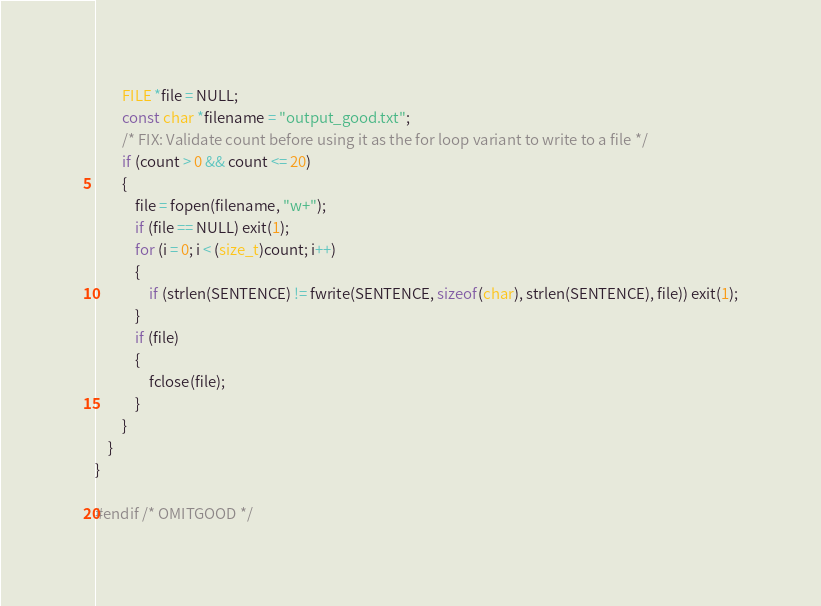<code> <loc_0><loc_0><loc_500><loc_500><_C_>        FILE *file = NULL;
        const char *filename = "output_good.txt";
        /* FIX: Validate count before using it as the for loop variant to write to a file */
        if (count > 0 && count <= 20)
        {
            file = fopen(filename, "w+");
            if (file == NULL) exit(1);
            for (i = 0; i < (size_t)count; i++)
            {
                if (strlen(SENTENCE) != fwrite(SENTENCE, sizeof(char), strlen(SENTENCE), file)) exit(1);
            }
            if (file)
            {
                fclose(file);
            }
        }
    }
}

#endif /* OMITGOOD */
</code> 